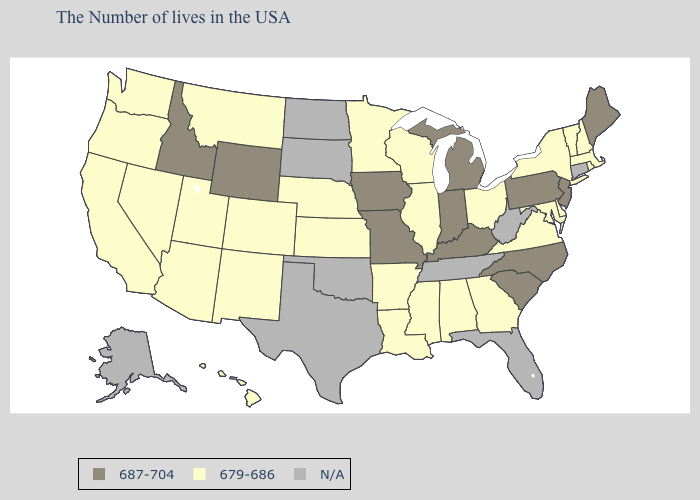Does Montana have the lowest value in the USA?
Answer briefly. Yes. What is the value of North Dakota?
Write a very short answer. N/A. Does Michigan have the lowest value in the USA?
Keep it brief. No. What is the lowest value in states that border Utah?
Quick response, please. 679-686. Among the states that border Illinois , which have the lowest value?
Keep it brief. Wisconsin. Among the states that border Washington , does Idaho have the lowest value?
Quick response, please. No. What is the value of Connecticut?
Concise answer only. N/A. Does the first symbol in the legend represent the smallest category?
Quick response, please. No. Name the states that have a value in the range 687-704?
Keep it brief. Maine, New Jersey, Pennsylvania, North Carolina, South Carolina, Michigan, Kentucky, Indiana, Missouri, Iowa, Wyoming, Idaho. Name the states that have a value in the range 679-686?
Keep it brief. Massachusetts, Rhode Island, New Hampshire, Vermont, New York, Delaware, Maryland, Virginia, Ohio, Georgia, Alabama, Wisconsin, Illinois, Mississippi, Louisiana, Arkansas, Minnesota, Kansas, Nebraska, Colorado, New Mexico, Utah, Montana, Arizona, Nevada, California, Washington, Oregon, Hawaii. What is the highest value in states that border Maryland?
Answer briefly. 687-704. What is the value of Maine?
Quick response, please. 687-704. 